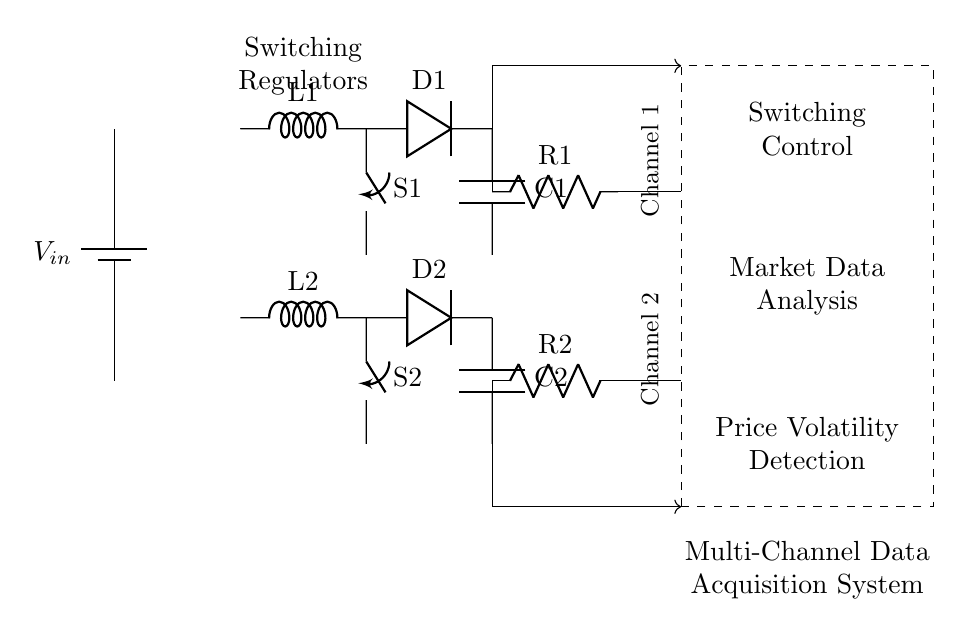what is the type of power supply used in this circuit? The circuit uses a battery, as indicated by the symbol and label for V_in. A battery provides a stable voltage source for powering the components.
Answer: battery how many switching regulators are present in the circuit? There are two switching regulators shown in the circuit, each represented by an inductor and associated components. They are labeled L1 and L2.
Answer: two what is the function of the control logic section? The control logic section serves three purposes: Switching Control, Market Data Analysis, and Price Volatility Detection, as indicated by the labels within the dashed rectangle.
Answer: regulate and analyze what are the output channels of the data acquisition system? The output channels are labeled Channel 1 and Channel 2, which represent the two paths for data acquisition from the regulators in the circuit.
Answer: Channel 1 and Channel 2 what is the role of the inductors in this circuit? The inductors (L1 and L2) function as energy storage components in the switching regulators, smoothing the current flow by storing and releasing energy as needed to maintain a stable output voltage.
Answer: energy storage how does feedback influence switching regulators in this circuit? Feedback is used to adjust the switching regulators' operation by providing data about the output voltage and current, ensuring that the circuit maintains a stable performance despite changes in input or load conditions.
Answer: stabilizes performance 